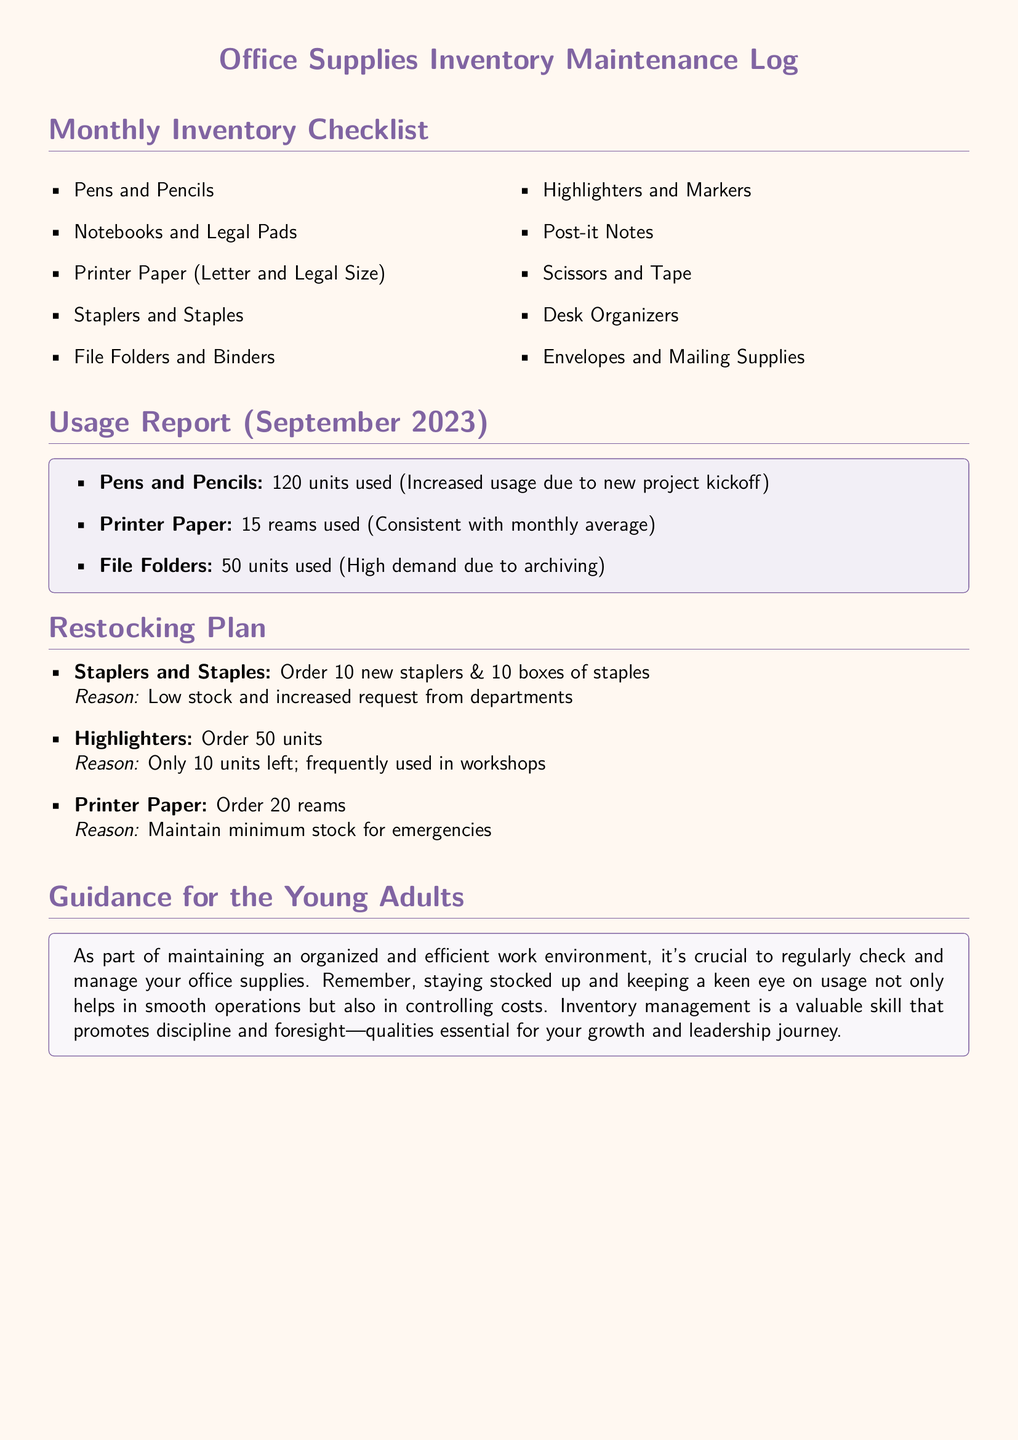What items are listed in the monthly inventory checklist? The items listed in the monthly inventory checklist are those needed to maintain office supplies.
Answer: Pens and Pencils, Notebooks and Legal Pads, Printer Paper, Staplers and Staples, File Folders and Binders, Highlighters and Markers, Post-it Notes, Scissors and Tape, Desk Organizers, Envelopes and Mailing Supplies How many units of printer paper were used in September 2023? The usage report specifies the number of units consumed in the month for each item.
Answer: 15 reams What is the reason for ordering more staplers and staples? The restocking plan includes reasons for each item that requires replenishment.
Answer: Low stock and increased request from departments How many highlighters are left before restocking is needed? The restocking plan states how many highlighters are currently available and the order needed.
Answer: 10 units What is the total number of items in the Monthly Inventory Checklist? The checklist lists various items, and the total is counted to provide a sum.
Answer: 10 items Why is maintaining a stocked inventory important according to the document? The guidance section highlights the significance of inventory management for organizational efficiency.
Answer: Helps in smooth operations and controlling costs 